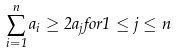Convert formula to latex. <formula><loc_0><loc_0><loc_500><loc_500>\sum _ { i = 1 } ^ { n } a _ { i } \geq 2 a _ { j } f o r 1 \leq j \leq n</formula> 